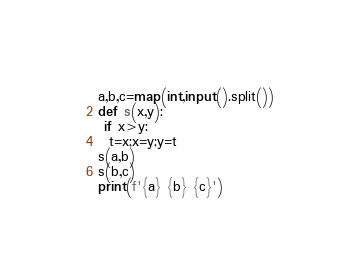<code> <loc_0><loc_0><loc_500><loc_500><_Python_>a,b,c=map(int,input().split())
def s(x,y):
 if x>y:
  t=x;x=y;y=t
s(a,b)
s(b,c)
print(f'{a} {b} {c}')</code> 